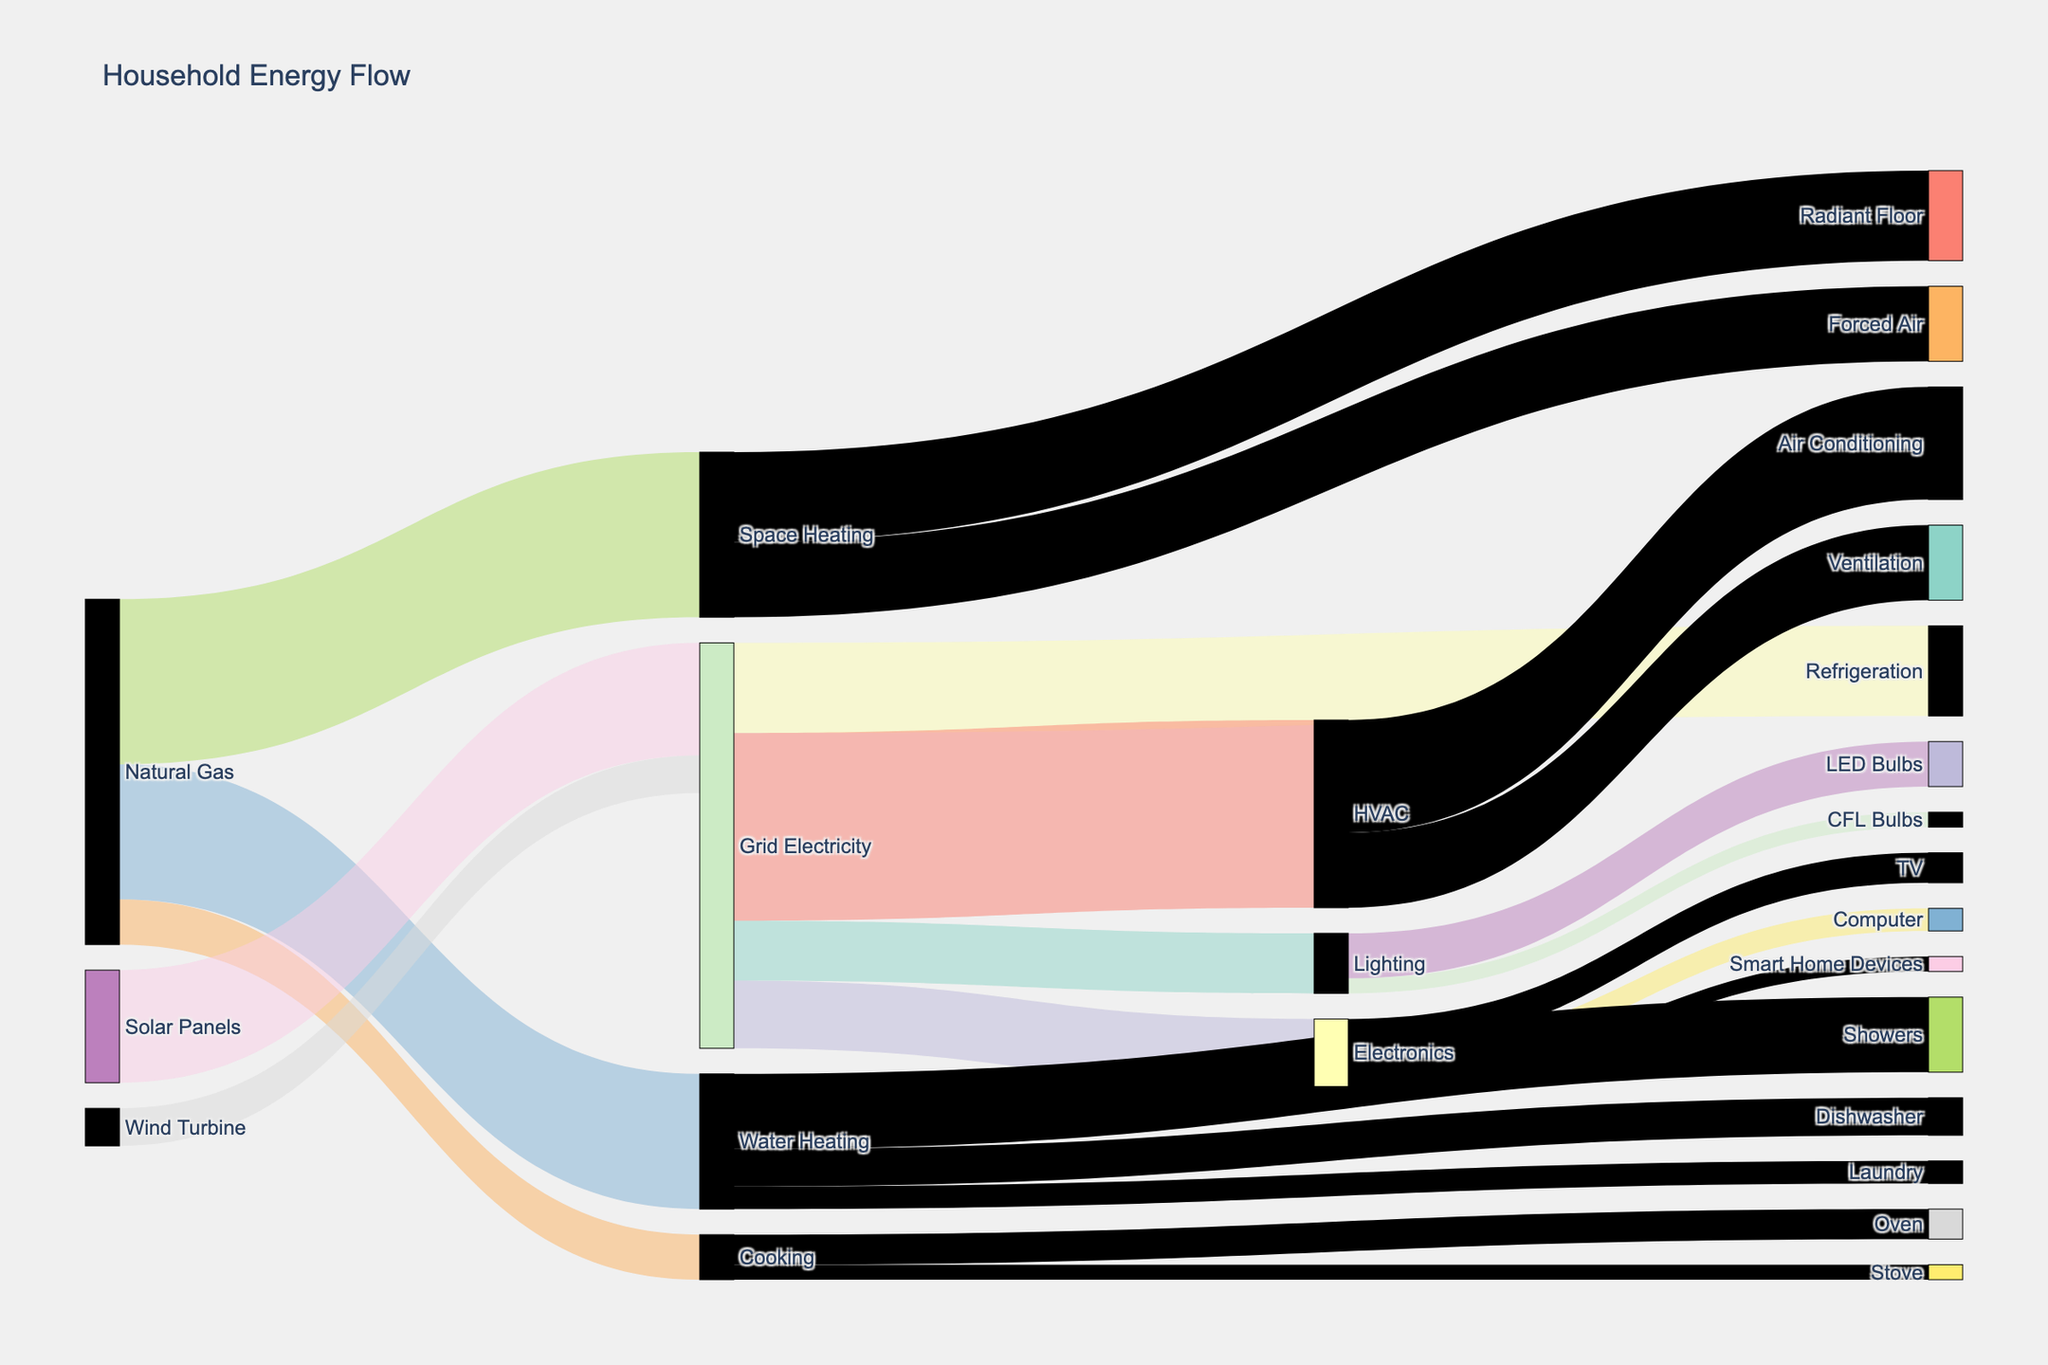what is the title of the figure? The title is placed at the top of the figure and gives an overview of what the figure represents. By looking at the top, you can see the title "Household Energy Flow".
Answer: Household Energy Flow Which energy source contributes the most to space heating? Space Heating is connected to two energy sources: "Natural Gas" and "Grid Electricity". By observing the thickness of the connections or the values, "Natural Gas" contributes 2200 units to Space Heating.
Answer: Natural Gas How much energy from grid electricity is used for lighting? By following the link from "Grid Electricity" to "Lighting", the value at the end of the connection shows 800 units.
Answer: 800 What is the total energy used for HVAC? HVAC has incoming connections from "Grid Electricity" with 2500 units.
Answer: 2500 What fraction of the total energy for lighting is used by LED bulbs? Lighting has a total of 800 units. Out of these, 600 units go to LED bulbs. The fraction is 600/800.
Answer: 3/4 or 0.75 Which end-use consumes the highest amount of energy? To find the highest consuming end-use, look at all the targets and their connected values. HVAC (connected to Air Conditioning and Ventilation) consumes 2500 units from Grid Electricity.
Answer: HVAC What are the main sources of grid electricity? The sources connected to Grid Electricity are "Solar Panels" providing 1500 units and "Wind Turbine" providing 500 units.
Answer: Solar Panels, Wind Turbine Which component of electronics consumes the least energy? The components in Electronics are Computer (300 units), TV (400 units), and Smart Home Devices (200 units). Smart Home Devices consume the least energy.
Answer: Smart Home Devices How does the energy for cooking break down between oven and stove? Cooking is divided into Oven and Stove, with respective energy values of 400 units and 200 units.
Answer: Oven: 400 units, Stove: 200 units What is the combined energy use for air conditioning and forced-air heating? Air Conditioning uses 1500 units (under HVAC) and Forced Air (under Space Heating) uses 1000 units. Sum: 1500 + 1000 = 2500 units.
Answer: 2500 units 